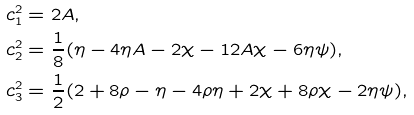Convert formula to latex. <formula><loc_0><loc_0><loc_500><loc_500>c _ { 1 } ^ { 2 } = & \ 2 A , \\ c _ { 2 } ^ { 2 } = & \ \frac { 1 } { 8 } ( \eta - 4 \eta A - 2 \chi - 1 2 A \chi - 6 \eta \psi ) , \\ c _ { 3 } ^ { 2 } = & \ \frac { 1 } { 2 } ( 2 + 8 \rho - \eta - 4 \rho \eta + 2 \chi + 8 \rho \chi - 2 \eta \psi ) ,</formula> 